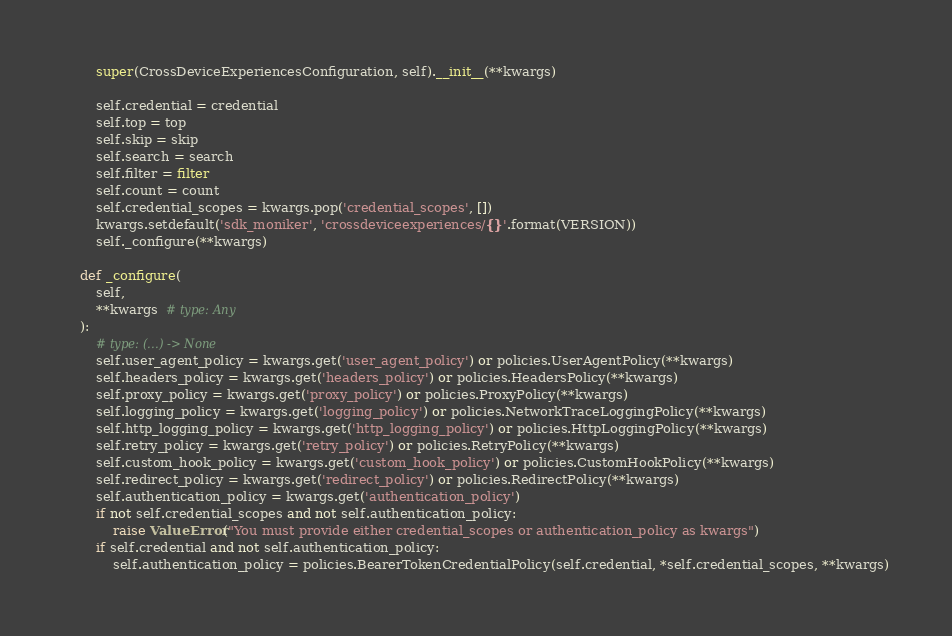<code> <loc_0><loc_0><loc_500><loc_500><_Python_>        super(CrossDeviceExperiencesConfiguration, self).__init__(**kwargs)

        self.credential = credential
        self.top = top
        self.skip = skip
        self.search = search
        self.filter = filter
        self.count = count
        self.credential_scopes = kwargs.pop('credential_scopes', [])
        kwargs.setdefault('sdk_moniker', 'crossdeviceexperiences/{}'.format(VERSION))
        self._configure(**kwargs)

    def _configure(
        self,
        **kwargs  # type: Any
    ):
        # type: (...) -> None
        self.user_agent_policy = kwargs.get('user_agent_policy') or policies.UserAgentPolicy(**kwargs)
        self.headers_policy = kwargs.get('headers_policy') or policies.HeadersPolicy(**kwargs)
        self.proxy_policy = kwargs.get('proxy_policy') or policies.ProxyPolicy(**kwargs)
        self.logging_policy = kwargs.get('logging_policy') or policies.NetworkTraceLoggingPolicy(**kwargs)
        self.http_logging_policy = kwargs.get('http_logging_policy') or policies.HttpLoggingPolicy(**kwargs)
        self.retry_policy = kwargs.get('retry_policy') or policies.RetryPolicy(**kwargs)
        self.custom_hook_policy = kwargs.get('custom_hook_policy') or policies.CustomHookPolicy(**kwargs)
        self.redirect_policy = kwargs.get('redirect_policy') or policies.RedirectPolicy(**kwargs)
        self.authentication_policy = kwargs.get('authentication_policy')
        if not self.credential_scopes and not self.authentication_policy:
            raise ValueError("You must provide either credential_scopes or authentication_policy as kwargs")
        if self.credential and not self.authentication_policy:
            self.authentication_policy = policies.BearerTokenCredentialPolicy(self.credential, *self.credential_scopes, **kwargs)
</code> 